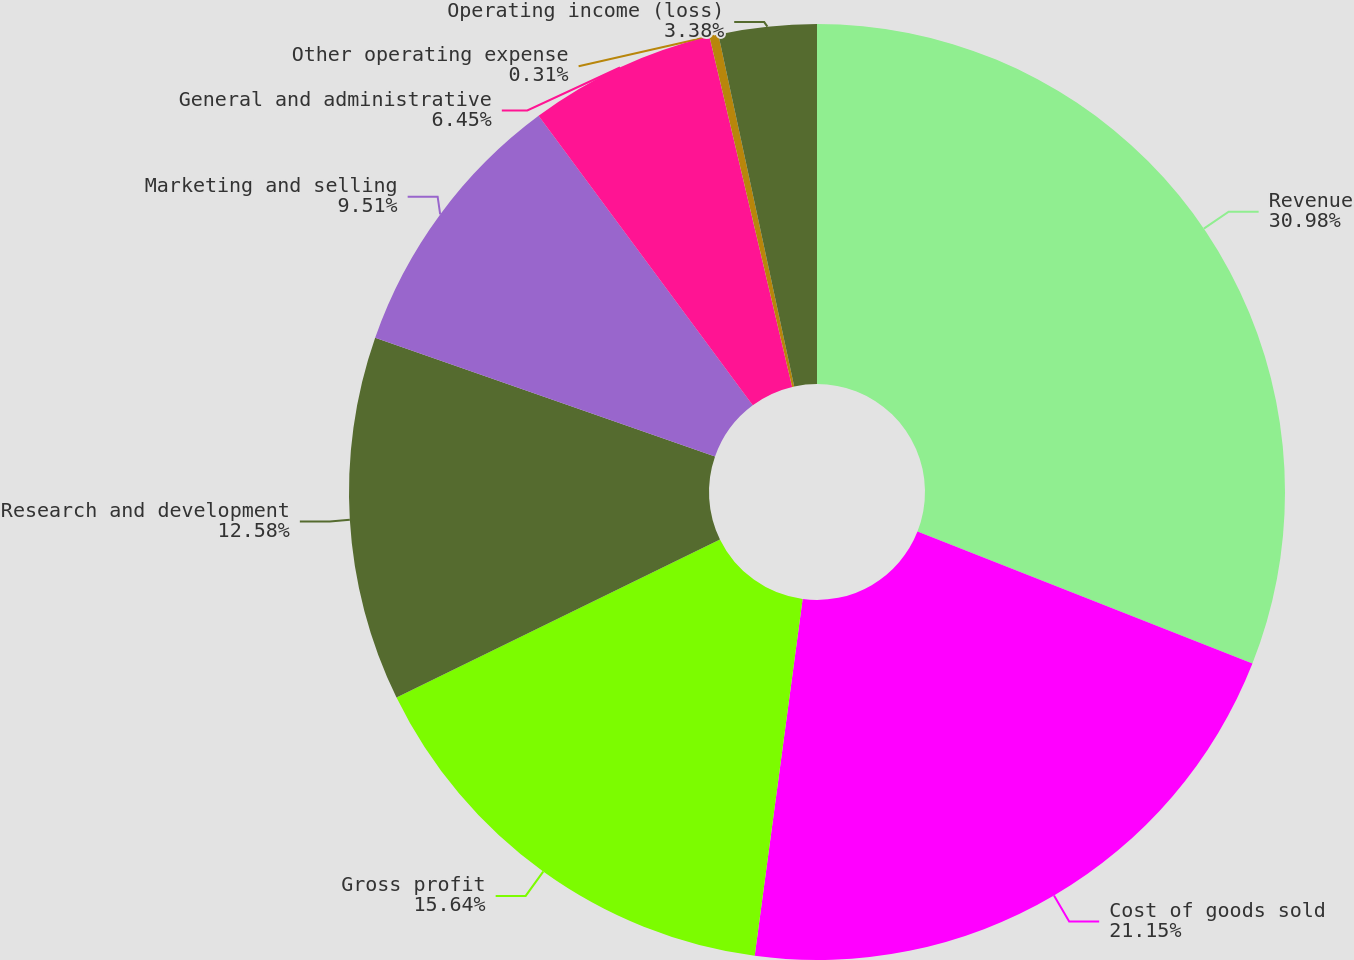Convert chart. <chart><loc_0><loc_0><loc_500><loc_500><pie_chart><fcel>Revenue<fcel>Cost of goods sold<fcel>Gross profit<fcel>Research and development<fcel>Marketing and selling<fcel>General and administrative<fcel>Other operating expense<fcel>Operating income (loss)<nl><fcel>30.97%<fcel>21.15%<fcel>15.64%<fcel>12.58%<fcel>9.51%<fcel>6.45%<fcel>0.31%<fcel>3.38%<nl></chart> 